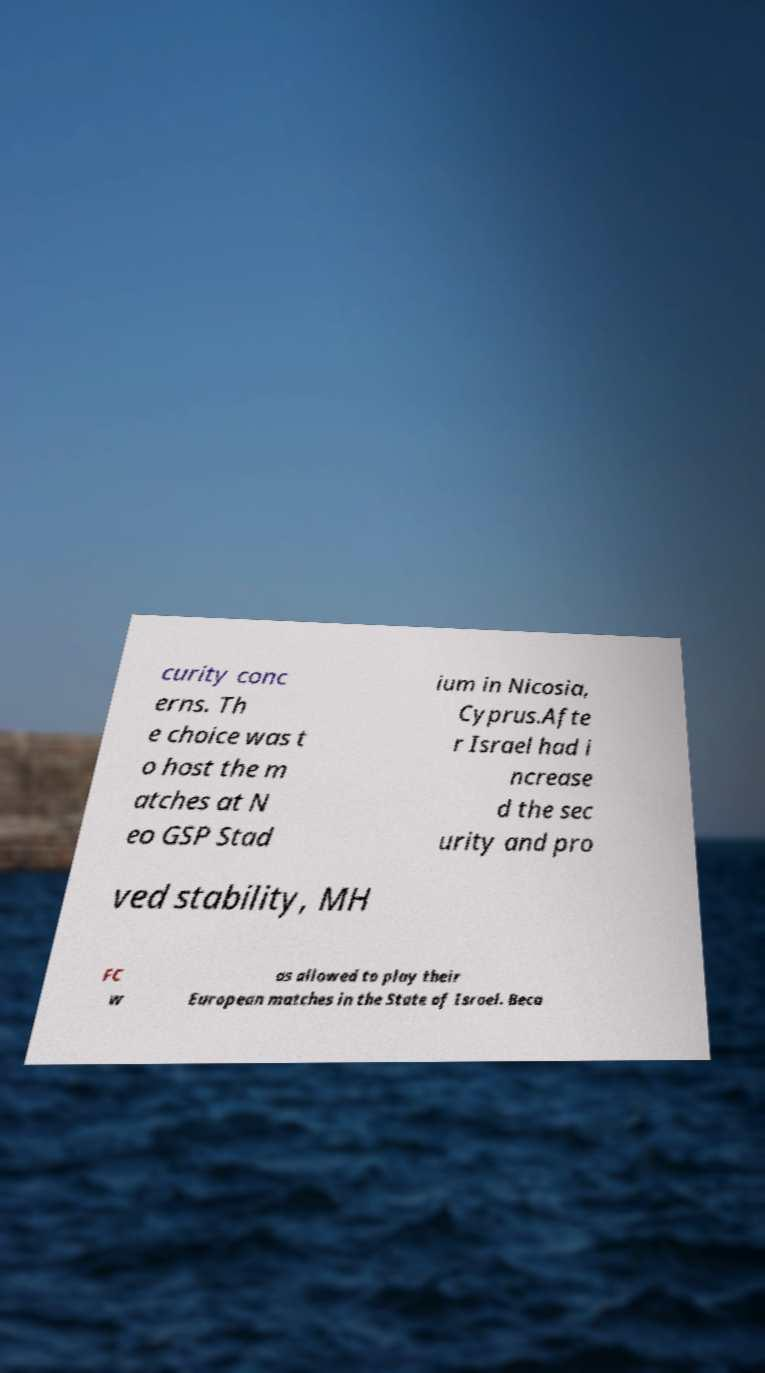Can you accurately transcribe the text from the provided image for me? curity conc erns. Th e choice was t o host the m atches at N eo GSP Stad ium in Nicosia, Cyprus.Afte r Israel had i ncrease d the sec urity and pro ved stability, MH FC w as allowed to play their European matches in the State of Israel. Beca 